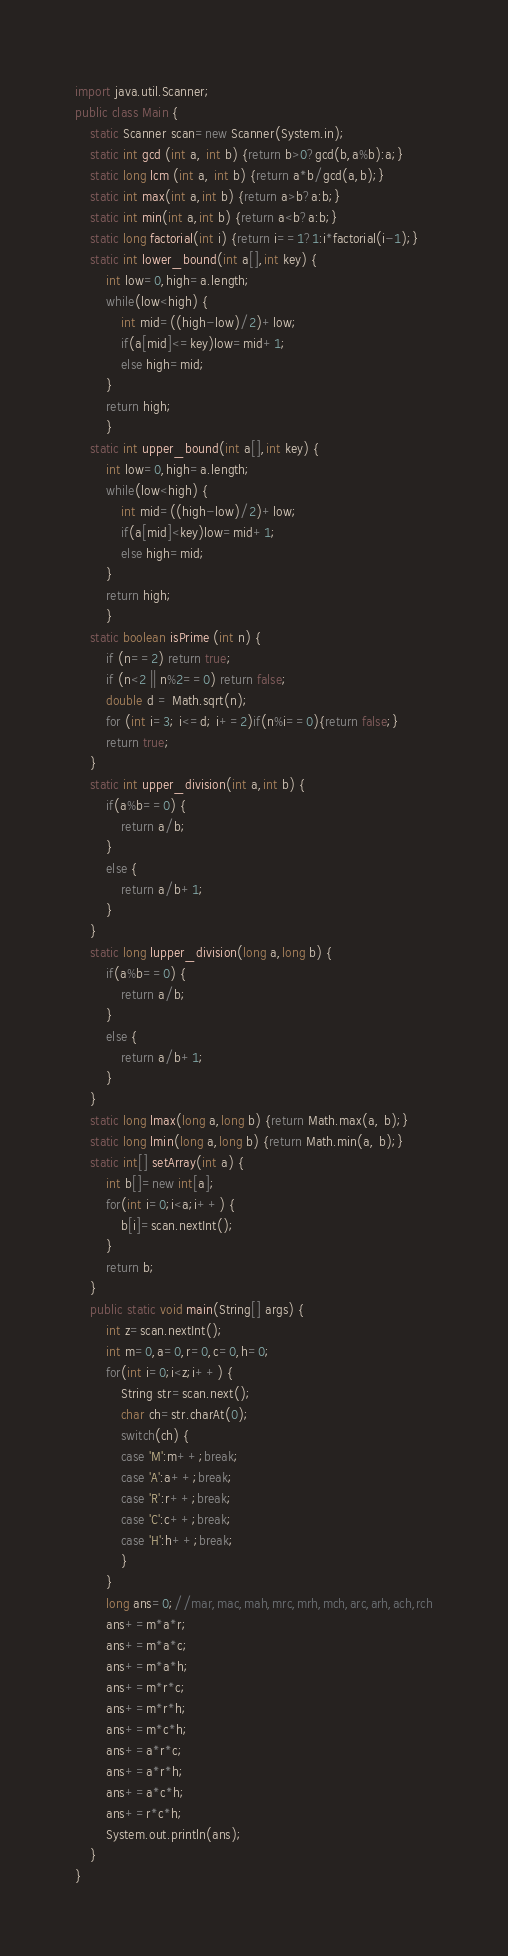Convert code to text. <code><loc_0><loc_0><loc_500><loc_500><_Java_>import java.util.Scanner;
public class Main {
	static Scanner scan=new Scanner(System.in);
	static int gcd (int a, int b) {return b>0?gcd(b,a%b):a;}
	static long lcm (int a, int b) {return a*b/gcd(a,b);}
	static int max(int a,int b) {return a>b?a:b;}
	static int min(int a,int b) {return a<b?a:b;}
	static long factorial(int i) {return i==1?1:i*factorial(i-1);}
	static int lower_bound(int a[],int key) {
		int low=0,high=a.length;
		while(low<high) {
			int mid=((high-low)/2)+low;
			if(a[mid]<=key)low=mid+1;
			else high=mid;
		}
		return high;
		}
	static int upper_bound(int a[],int key) {
		int low=0,high=a.length;
		while(low<high) {
			int mid=((high-low)/2)+low;
			if(a[mid]<key)low=mid+1;
			else high=mid;
		}
		return high;
		}
	static boolean isPrime (int n) {
		if (n==2) return true;
		if (n<2 || n%2==0) return false;
		double d = Math.sqrt(n);
		for (int i=3; i<=d; i+=2)if(n%i==0){return false;}
		return true;
	}
	static int upper_division(int a,int b) {
		if(a%b==0) {
			return a/b;
		}
		else {
			return a/b+1;
		}
	}
	static long lupper_division(long a,long b) {
		if(a%b==0) {
			return a/b;
		}
		else {
			return a/b+1;
		}
	}
	static long lmax(long a,long b) {return Math.max(a, b);}
	static long lmin(long a,long b) {return Math.min(a, b);}
	static int[] setArray(int a) {
		int b[]=new int[a];
		for(int i=0;i<a;i++) {
			b[i]=scan.nextInt();
		}
		return b;
	}
	public static void main(String[] args) {
		int z=scan.nextInt();
		int m=0,a=0,r=0,c=0,h=0;
		for(int i=0;i<z;i++) {
			String str=scan.next();
			char ch=str.charAt(0);
			switch(ch) {
			case 'M':m++;break;
			case 'A':a++;break;
			case 'R':r++;break;
			case 'C':c++;break;
			case 'H':h++;break;
			}
		}
		long ans=0;//mar,mac,mah,mrc,mrh,mch,arc,arh,ach,rch
		ans+=m*a*r;
		ans+=m*a*c;
		ans+=m*a*h;
		ans+=m*r*c;
		ans+=m*r*h;
		ans+=m*c*h;
		ans+=a*r*c;
		ans+=a*r*h;
		ans+=a*c*h;
		ans+=r*c*h;
		System.out.println(ans);
	}
}</code> 